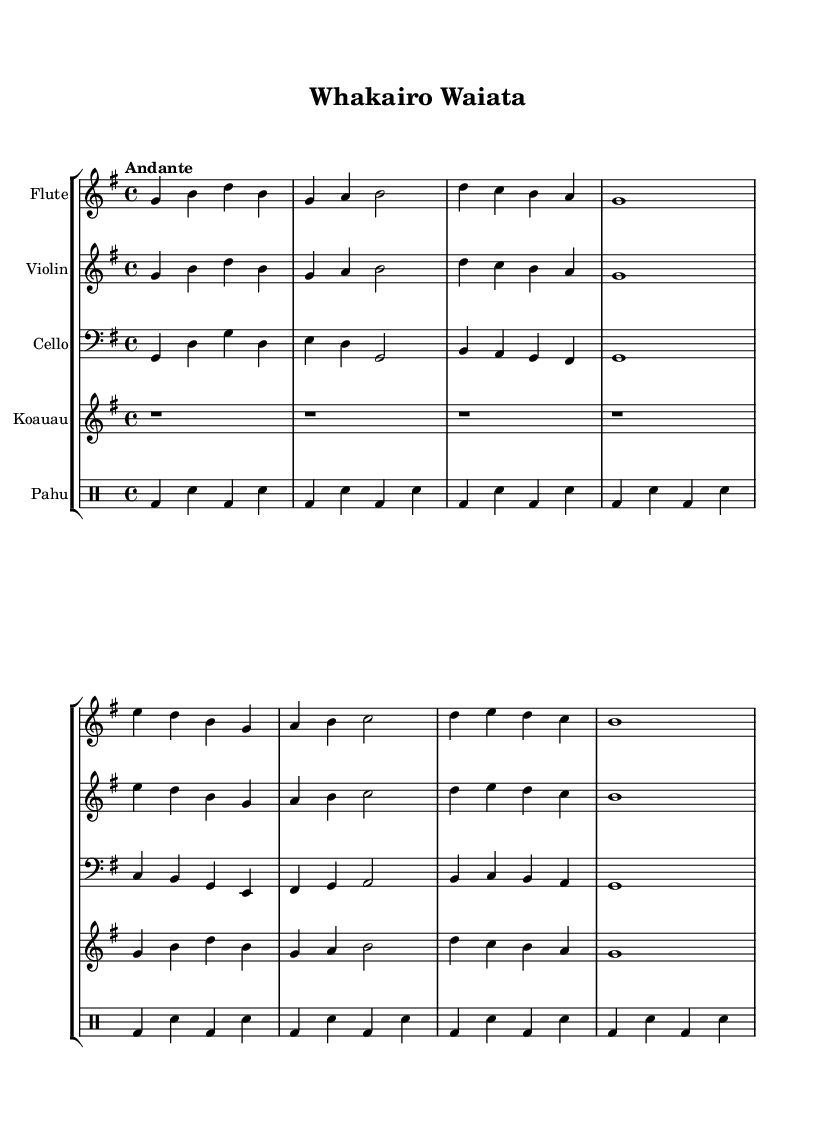What is the key signature of this music? The key signature is G major, which has one sharp (F#) indicated at the beginning of the staff.
Answer: G major What is the time signature of the piece? The time signature is 4/4, which indicates four beats per measure and a quarter note gets one beat. This is shown at the beginning of the sheet music.
Answer: 4/4 What is the tempo marking of this piece? The tempo marking is "Andante", which suggests a moderate pace, typically around 76 to 108 beats per minute. This is indicated in the tempo marking at the start of the score.
Answer: Andante How many instruments are featured in the score? There are four instruments featured in the score: flute, violin, cello, and koauau (a Māori flute). This is evident from the separate staffs labeled for each instrument in the score.
Answer: Four What type of drum is included in this piece? The drum used in this piece is called a Pahu, which is a Māori traditional drum. This is indicated in the drum staff labeled as "Pahu" in the score.
Answer: Pahu What is the total number of measures in the flute music? The flute music contains a total of six measures, as counted from the beginning of the section. Each group of notes separated by vertical lines indicates the end of a measure.
Answer: Six What style does this piece represent in relation to Māori culture? This piece represents a cultural fusion of classical music elements and Māori influences, particularly through the use of the koauau and Pahu, which are traditional Māori instruments. This theme is relevant to the inspiration behind the composition.
Answer: Fusion 